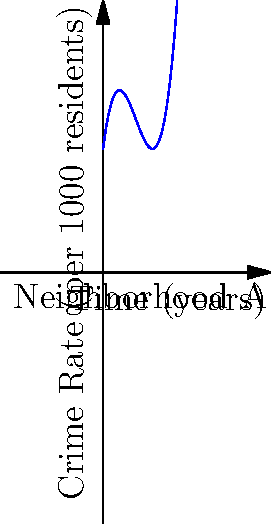As a reality show producer focusing on 'real-life crime' content, you're analyzing crime rate trends in different neighborhoods. The polynomial function $f(x) = 0.5x^3 - 4x^2 + 8x + 10$ models the crime rate per 1000 residents in Neighborhood A, where $x$ represents the number of years since the start of your observation. At what point in time does the crime rate reach its minimum, and how could this information be used to create compelling TV content? To find the minimum point of the crime rate function, we need to follow these steps:

1) Find the derivative of the function:
   $f'(x) = 1.5x^2 - 8x + 8$

2) Set the derivative equal to zero and solve for x:
   $1.5x^2 - 8x + 8 = 0$
   
3) This is a quadratic equation. We can solve it using the quadratic formula:
   $x = \frac{-b \pm \sqrt{b^2 - 4ac}}{2a}$
   
   Where $a = 1.5$, $b = -8$, and $c = 8$

4) Plugging in these values:
   $x = \frac{8 \pm \sqrt{64 - 48}}{3} = \frac{8 \pm 4}{3}$

5) This gives us two solutions:
   $x_1 = \frac{8 + 4}{3} = 4$ and $x_2 = \frac{8 - 4}{3} = \frac{4}{3}$

6) To determine which of these is the minimum, we can check the second derivative:
   $f''(x) = 3x - 8$
   
   At $x = 4$, $f''(4) = 4 > 0$, indicating a minimum.
   At $x = \frac{4}{3}$, $f''(\frac{4}{3}) = -4 < 0$, indicating a maximum.

Therefore, the crime rate reaches its minimum at $x = 4$, or 4 years after the start of observation.

For TV content, this information could be used to create a narrative arc about the neighborhood's struggle with crime, highlighting the factors that led to the decrease in crime rate over the first 4 years, and then exploring why the crime rate began to increase again after that point.
Answer: 4 years 